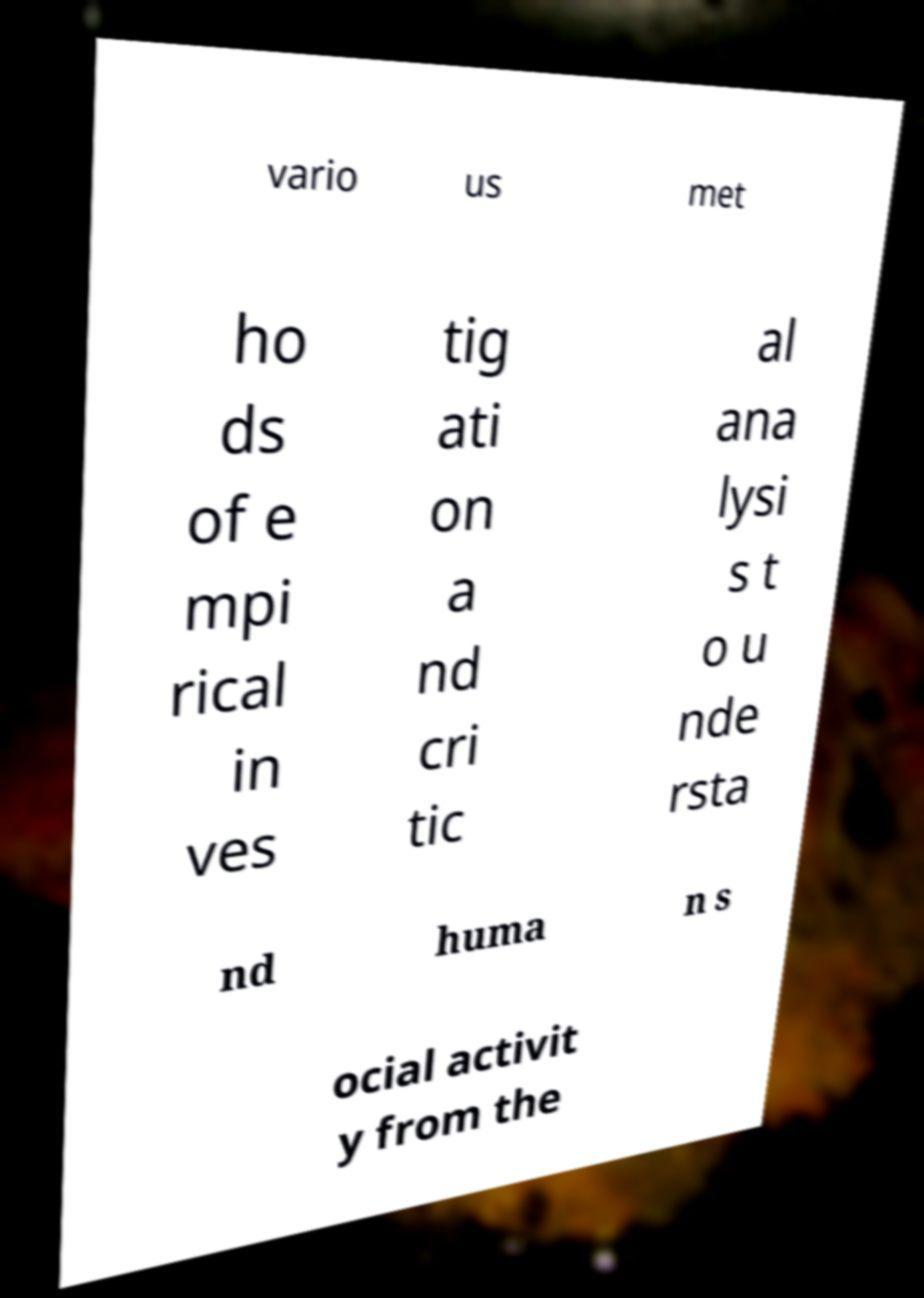There's text embedded in this image that I need extracted. Can you transcribe it verbatim? vario us met ho ds of e mpi rical in ves tig ati on a nd cri tic al ana lysi s t o u nde rsta nd huma n s ocial activit y from the 